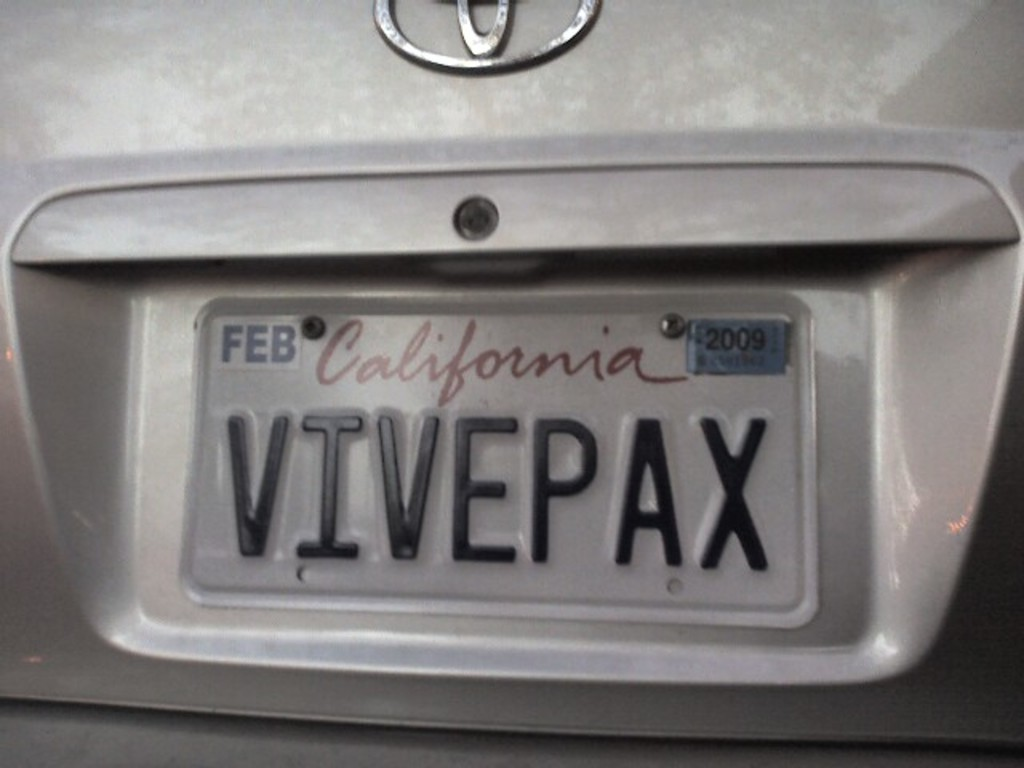Provide a one-sentence caption for the provided image. The image shows a gray car's rear with a California license plate labeled 'VIVEPAX' and a February 2009 registration tag, indicating the vehicle's registration has lapsed. 